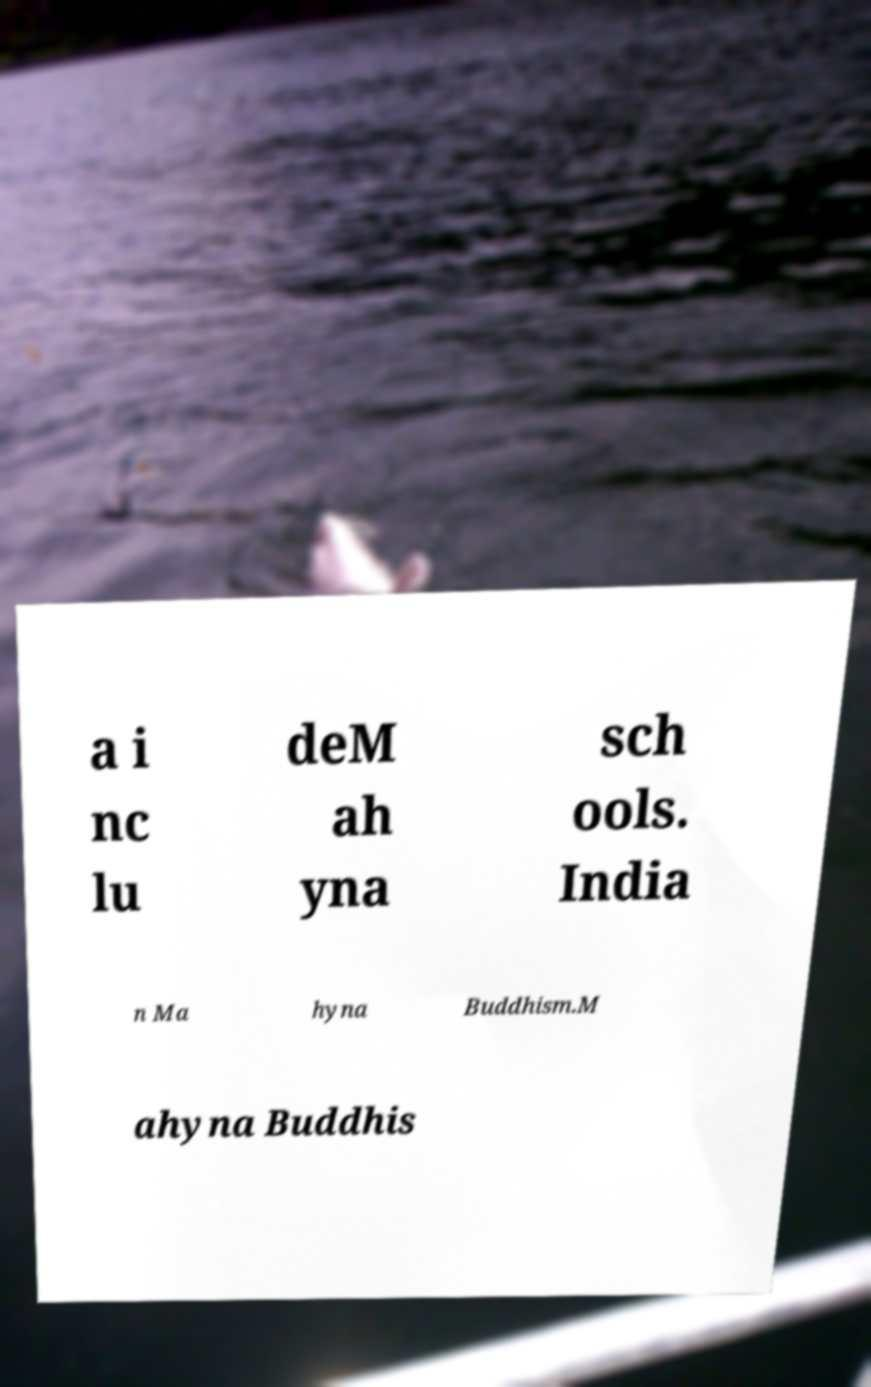Please identify and transcribe the text found in this image. a i nc lu deM ah yna sch ools. India n Ma hyna Buddhism.M ahyna Buddhis 